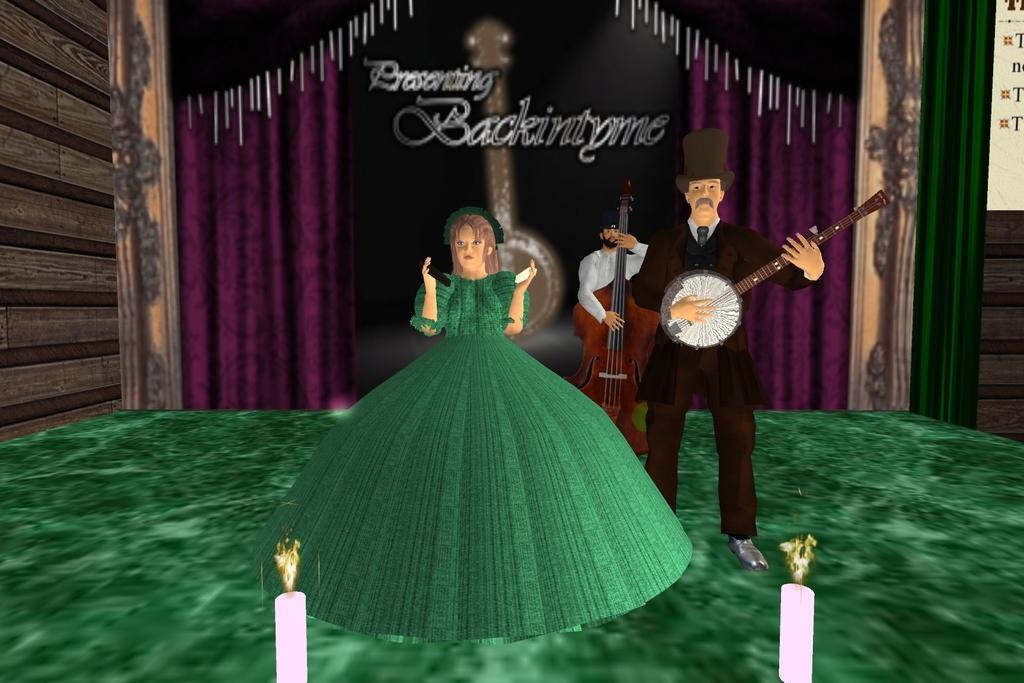Describe this image in one or two sentences. This is an animated image. We can see a woman is standing and there are two persons holding the musical instruments. At the bottom of the image, there are candles with flames. Behind the people, there are curtains and a board. In the top right corner of the image, it looks like a banner. On the left side of the image, there is a wooden wall. 